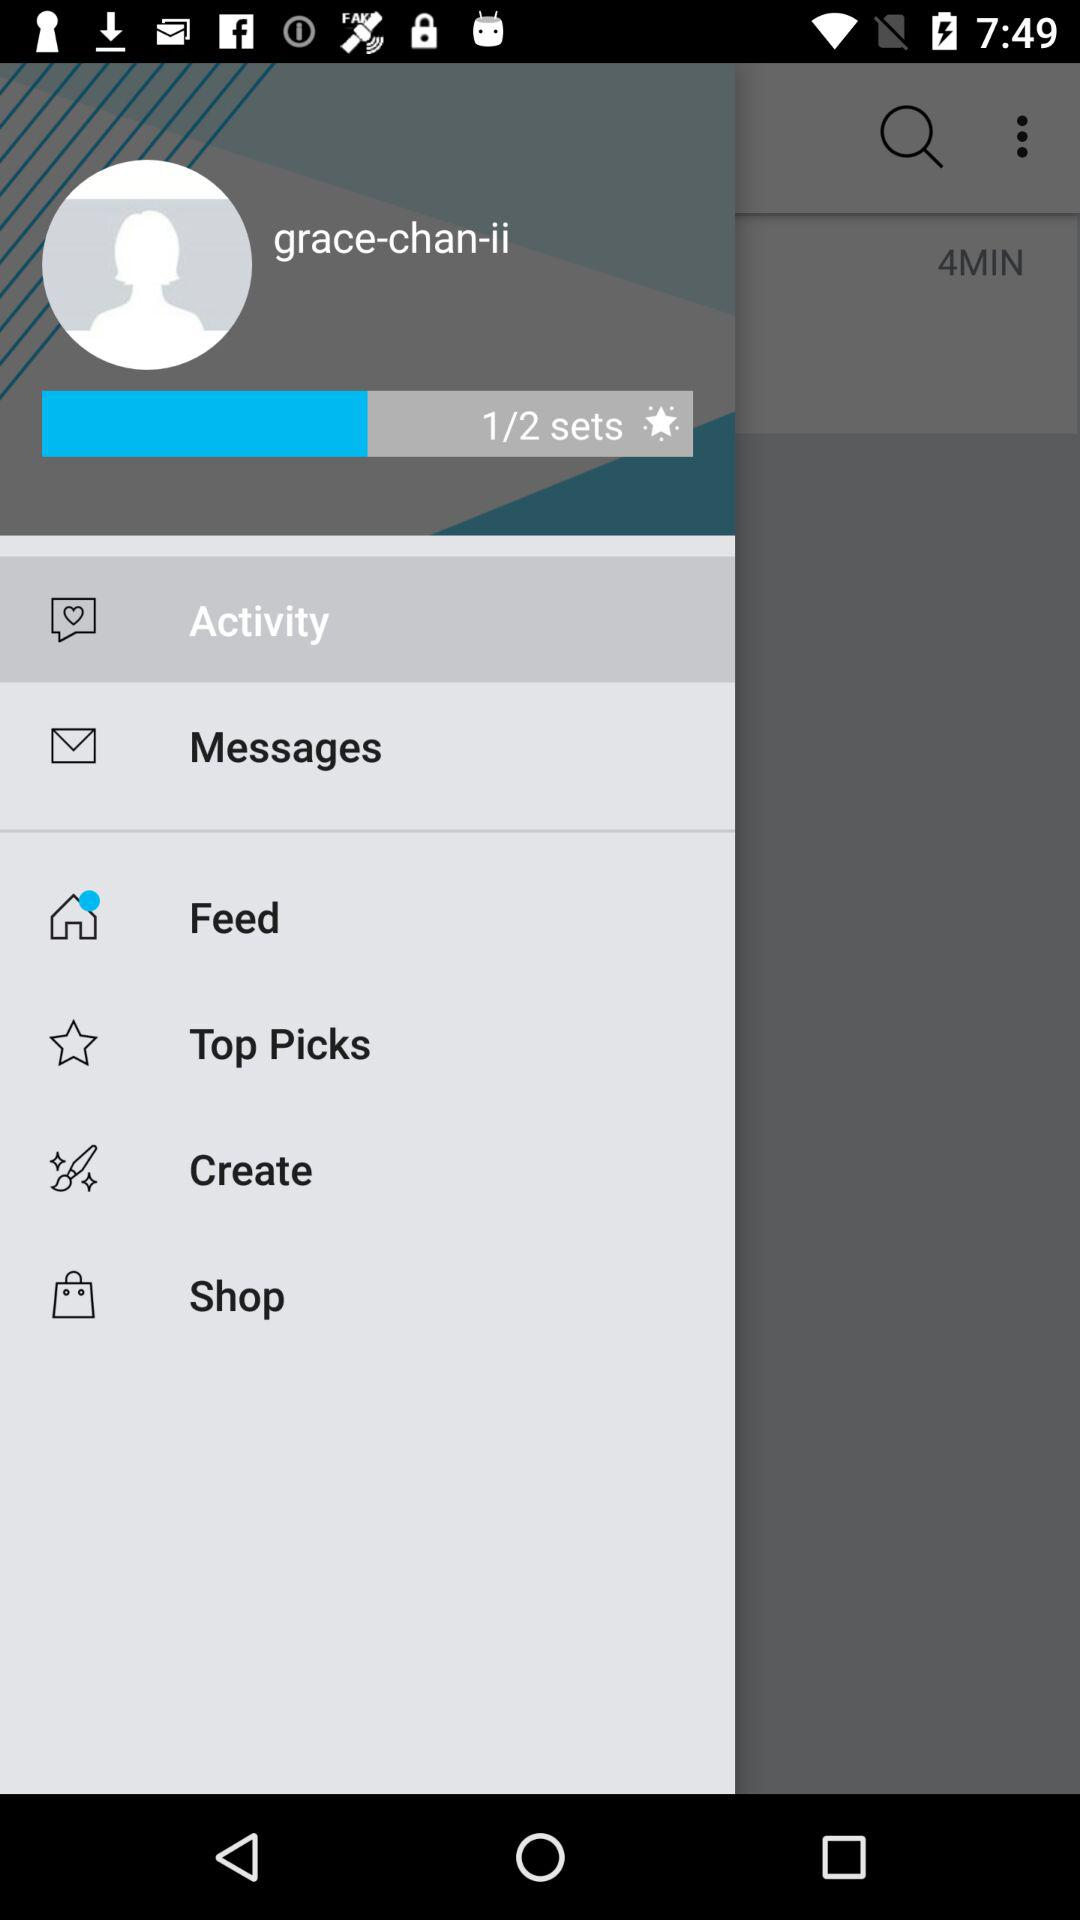What is the username? The username is "grace-chan-ii". 